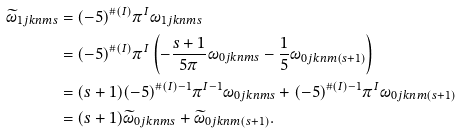<formula> <loc_0><loc_0><loc_500><loc_500>\widetilde { \omega } _ { 1 j k n m s } & = ( - 5 ) ^ { \# ( I ) } \pi ^ { I } \omega _ { 1 j k n m s } \\ & = ( - 5 ) ^ { \# ( I ) } \pi ^ { I } \left ( - \frac { s + 1 } { 5 \pi } \omega _ { 0 j k n m s } - \frac { 1 } { 5 } \omega _ { 0 j k n m ( s + 1 ) } \right ) \\ & = ( s + 1 ) ( - 5 ) ^ { \# ( I ) - 1 } \pi ^ { I - 1 } \omega _ { 0 j k n m s } + ( - 5 ) ^ { \# ( I ) - 1 } \pi ^ { I } \omega _ { 0 j k n m ( s + 1 ) } \\ & = ( s + 1 ) \widetilde { \omega } _ { 0 j k n m s } + \widetilde { \omega } _ { 0 j k n m ( s + 1 ) } .</formula> 